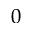<formula> <loc_0><loc_0><loc_500><loc_500>0</formula> 